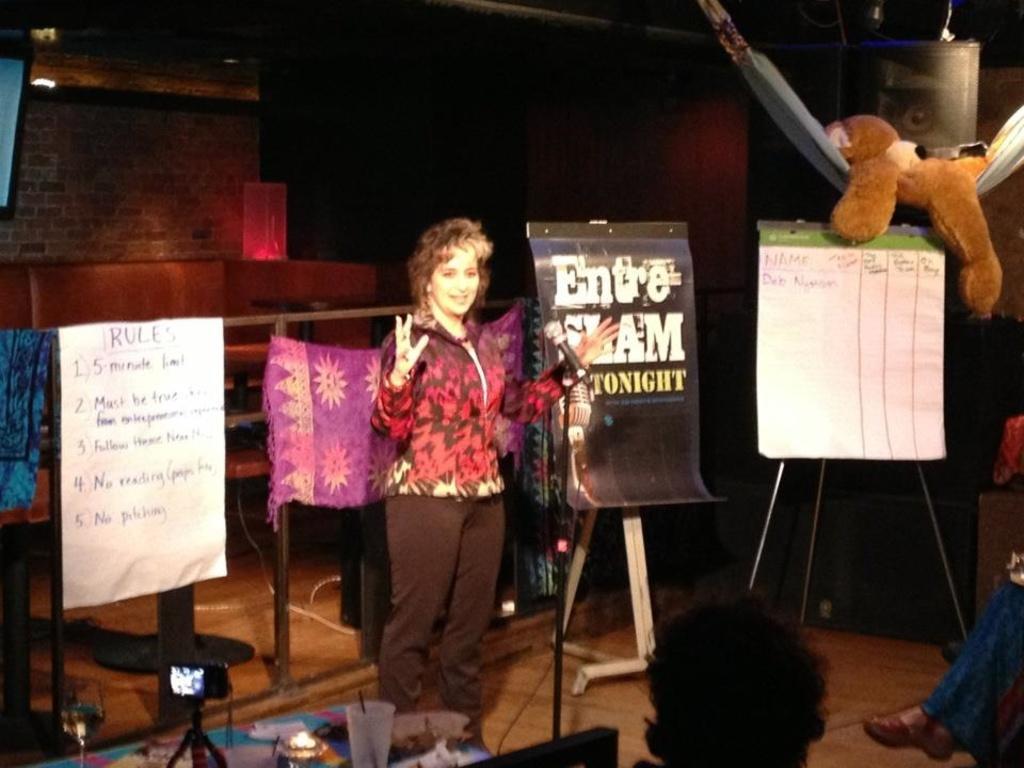In one or two sentences, can you explain what this image depicts? In this image I can see a woman standing on the floor and at the bottom there is the glass on the table. 